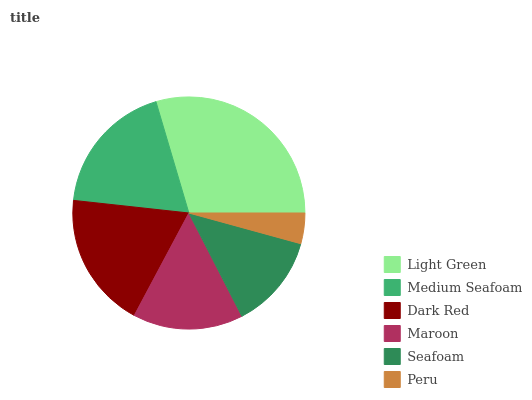Is Peru the minimum?
Answer yes or no. Yes. Is Light Green the maximum?
Answer yes or no. Yes. Is Medium Seafoam the minimum?
Answer yes or no. No. Is Medium Seafoam the maximum?
Answer yes or no. No. Is Light Green greater than Medium Seafoam?
Answer yes or no. Yes. Is Medium Seafoam less than Light Green?
Answer yes or no. Yes. Is Medium Seafoam greater than Light Green?
Answer yes or no. No. Is Light Green less than Medium Seafoam?
Answer yes or no. No. Is Medium Seafoam the high median?
Answer yes or no. Yes. Is Maroon the low median?
Answer yes or no. Yes. Is Peru the high median?
Answer yes or no. No. Is Peru the low median?
Answer yes or no. No. 